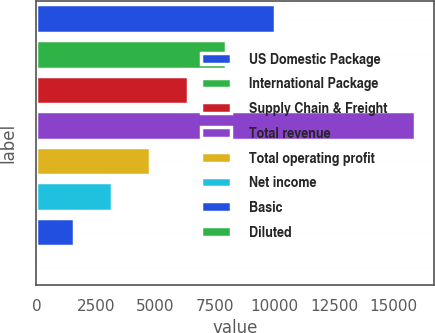<chart> <loc_0><loc_0><loc_500><loc_500><bar_chart><fcel>US Domestic Package<fcel>International Package<fcel>Supply Chain & Freight<fcel>Total revenue<fcel>Total operating profit<fcel>Net income<fcel>Basic<fcel>Diluted<nl><fcel>10004<fcel>7947.74<fcel>6358.29<fcel>15895<fcel>4768.84<fcel>3179.39<fcel>1589.94<fcel>0.49<nl></chart> 